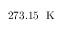Convert formula to latex. <formula><loc_0><loc_0><loc_500><loc_500>2 7 3 . 1 5 \, K</formula> 